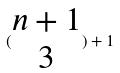Convert formula to latex. <formula><loc_0><loc_0><loc_500><loc_500>( \begin{matrix} n + 1 \\ 3 \end{matrix} ) + 1</formula> 